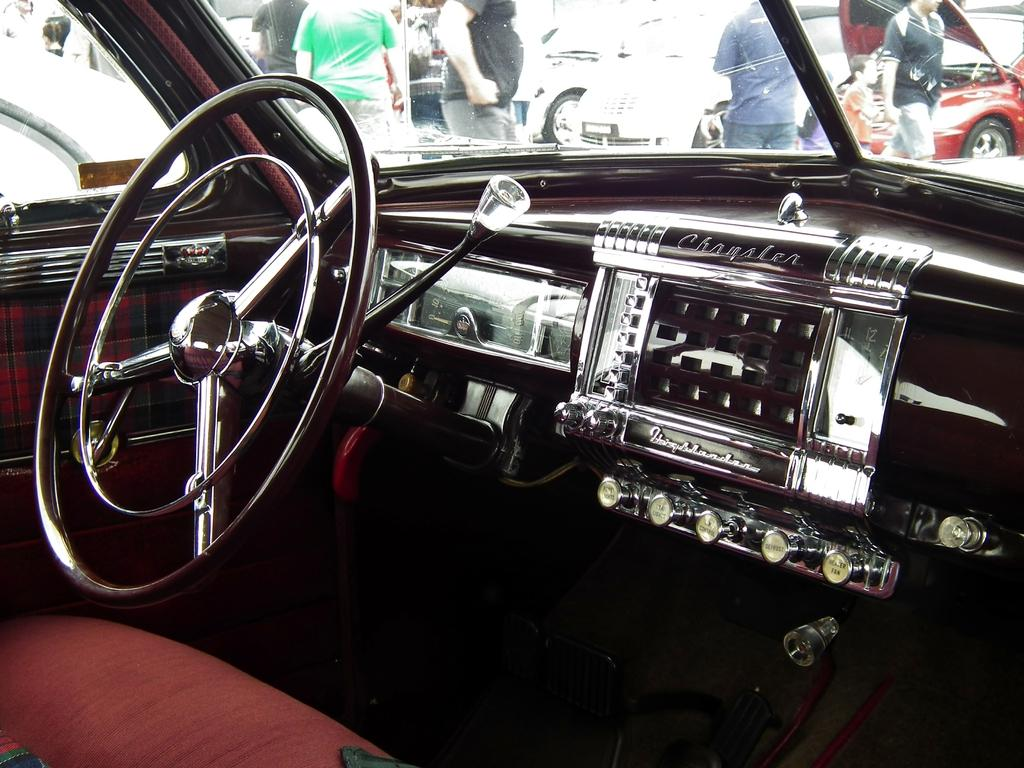What type of setting is depicted in the image? The image shows the interior of a car. What is the main control device in the car? There is a steering wheel in the car. How can the driver change gears in the car? There is a gear rod in the car. Who is visible in the image besides the driver? There are people in front of the car. What can be seen outside the car in the image? There are other cars visible in the image. What type of pan is being used to cook food in the car? There is no pan or cooking activity present in the image; it shows the interior of a car. What type of wine is being served in the car? There is no wine or serving activity present in the image; it shows the interior of a car. 